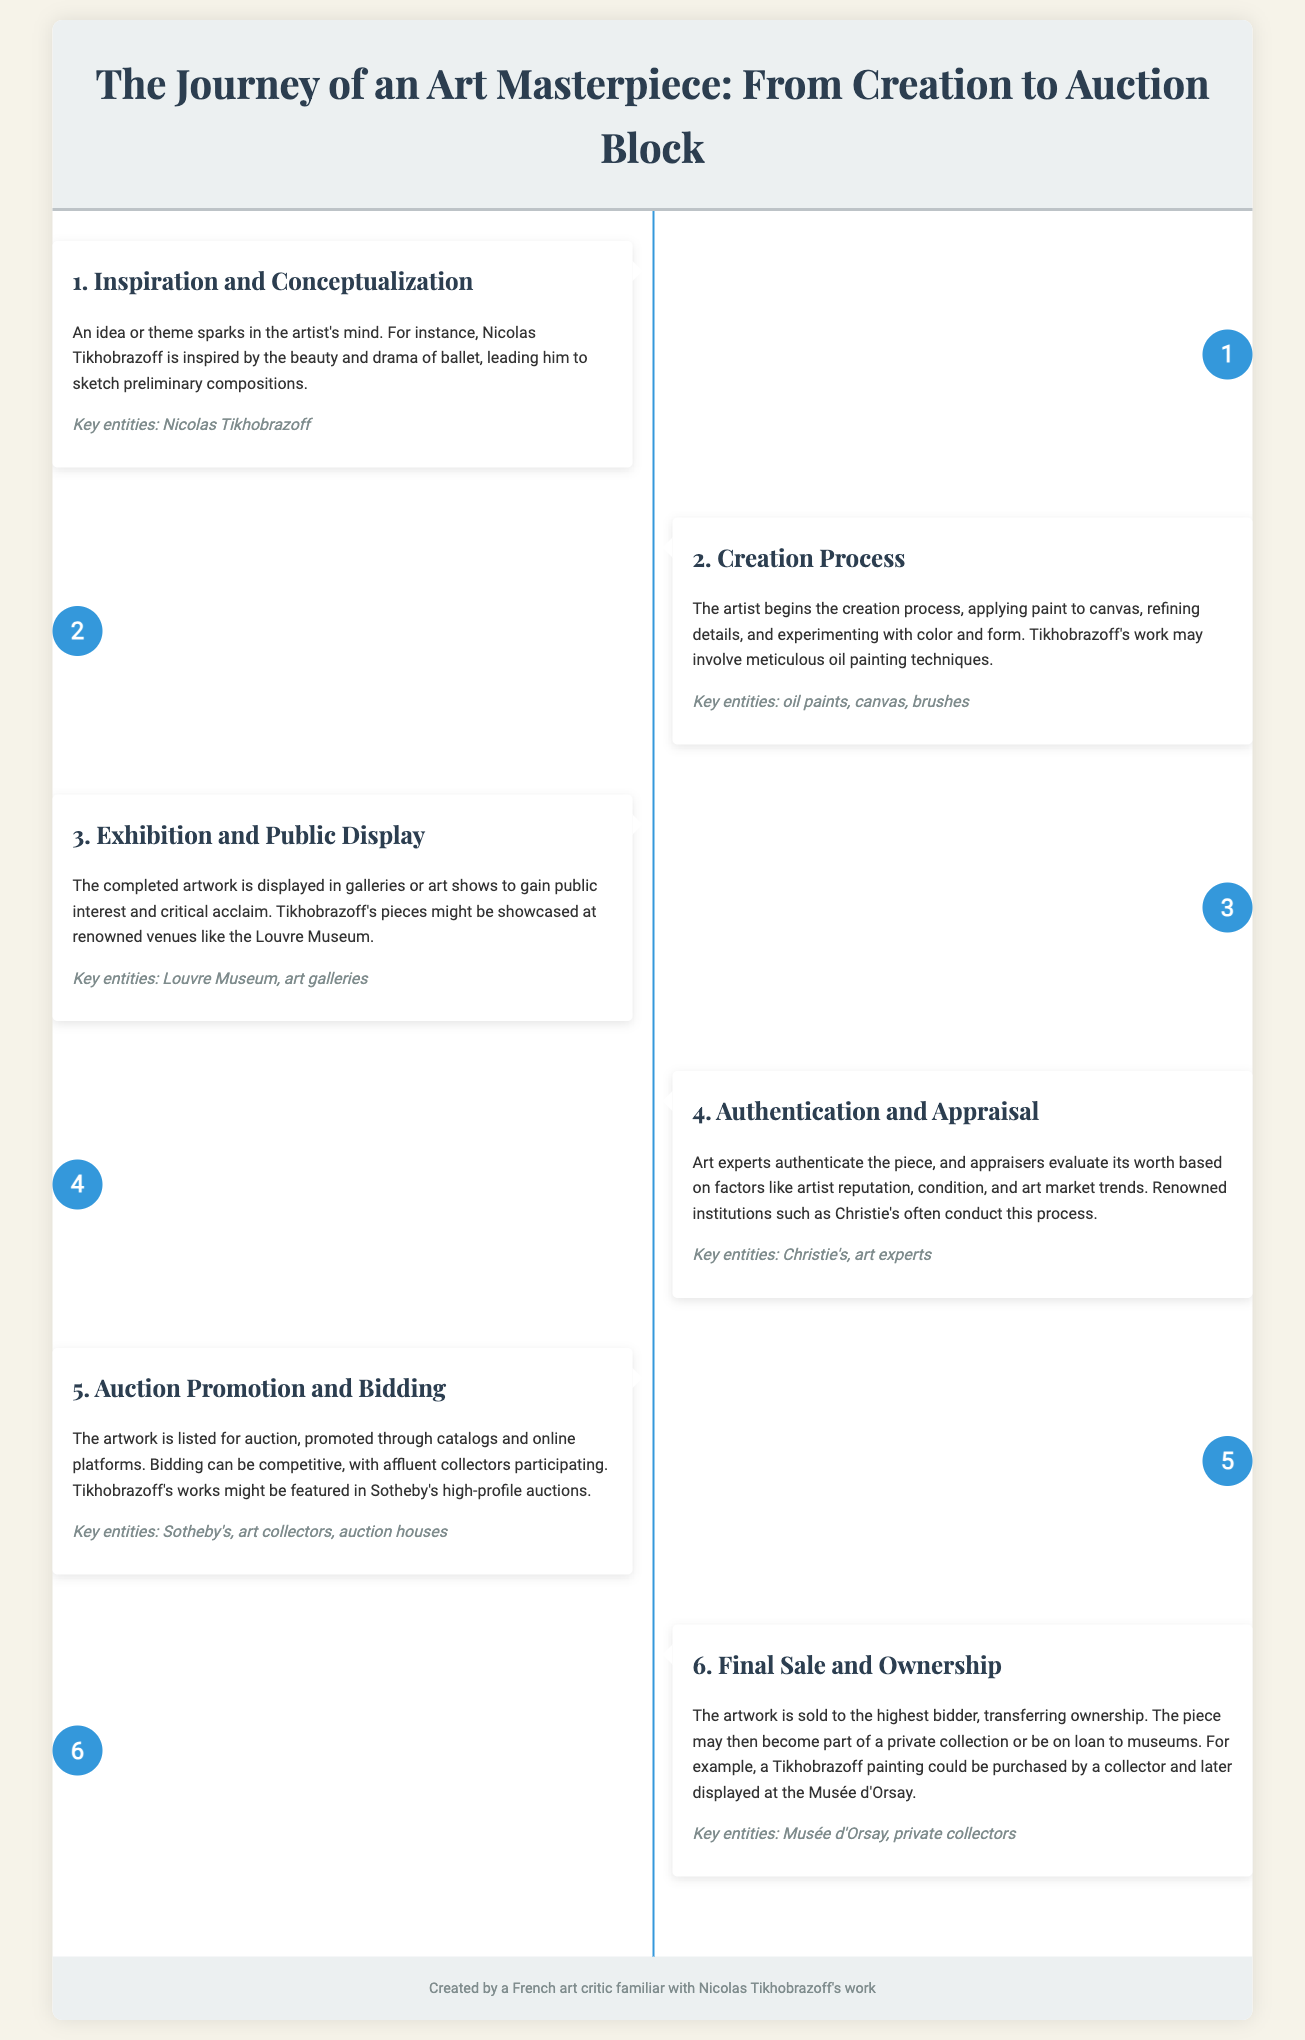What is the first step in the journey of an art masterpiece? The first step involves the initial spark of an idea or theme in the artist's mind.
Answer: Inspiration and Conceptualization Which artist is specifically mentioned in the infographic? The document highlights the work of a particular artist known for drawing inspiration from ballet.
Answer: Nicolas Tikhobrazoff What is used for the creation process according to the infographic? The infographic specifies the materials and tools used during the creation process of the artwork.
Answer: oil paints, canvas, brushes What prestigious venue might Tikhobrazoff's pieces be showcased at? The document mentions an iconic museum where completed artworks may be publicly displayed.
Answer: Louvre Museum What auction house is referenced in relation to Tikhobrazoff's works? The infographic discusses the auction promotion and bidding process, mentioning a specific auction house involved.
Answer: Sotheby's What is the final step in the journey of an art masterpiece? This step involves the sale of the artwork and the transfer of ownership to a new party.
Answer: Final Sale and Ownership Which museum might display a Tikhobrazoff painting after purchase? The document suggests a specific museum where a purchased artwork might be displayed.
Answer: Musée d'Orsay What aspect of the artwork is evaluated during the authentication and appraisal step? The document outlines the elements that are considered when determining an artwork's value and originality.
Answer: artist reputation, condition, and art market trends How many total steps are outlined in the journey of an art masterpiece? The infographic presents distinct sequential processes that illustrate the journey from creation to sale.
Answer: 6 